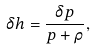<formula> <loc_0><loc_0><loc_500><loc_500>\delta h = \frac { \delta p } { p + \rho } ,</formula> 